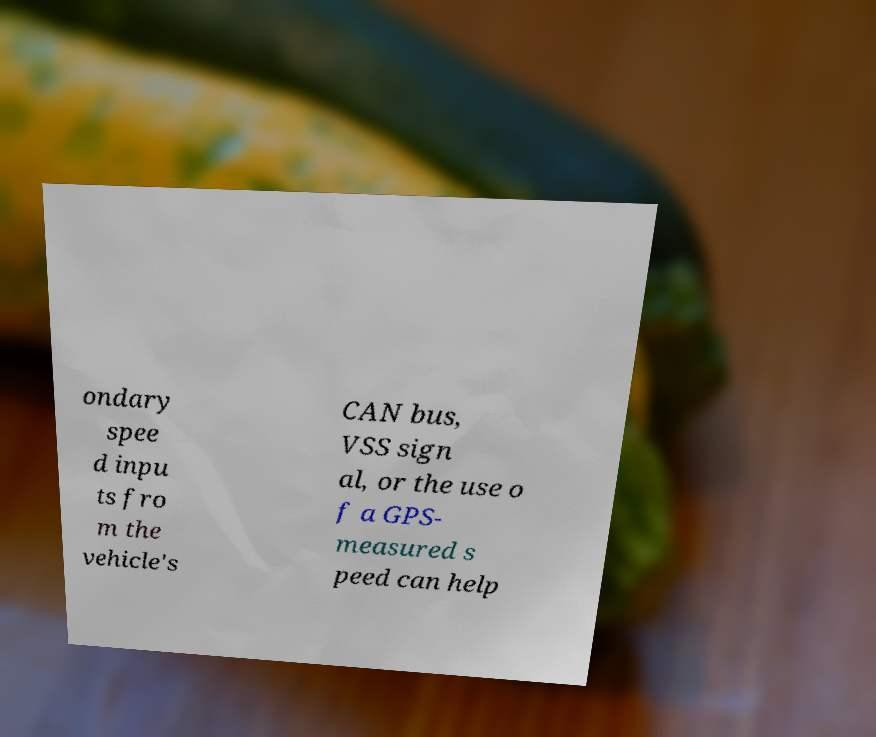Can you accurately transcribe the text from the provided image for me? ondary spee d inpu ts fro m the vehicle's CAN bus, VSS sign al, or the use o f a GPS- measured s peed can help 